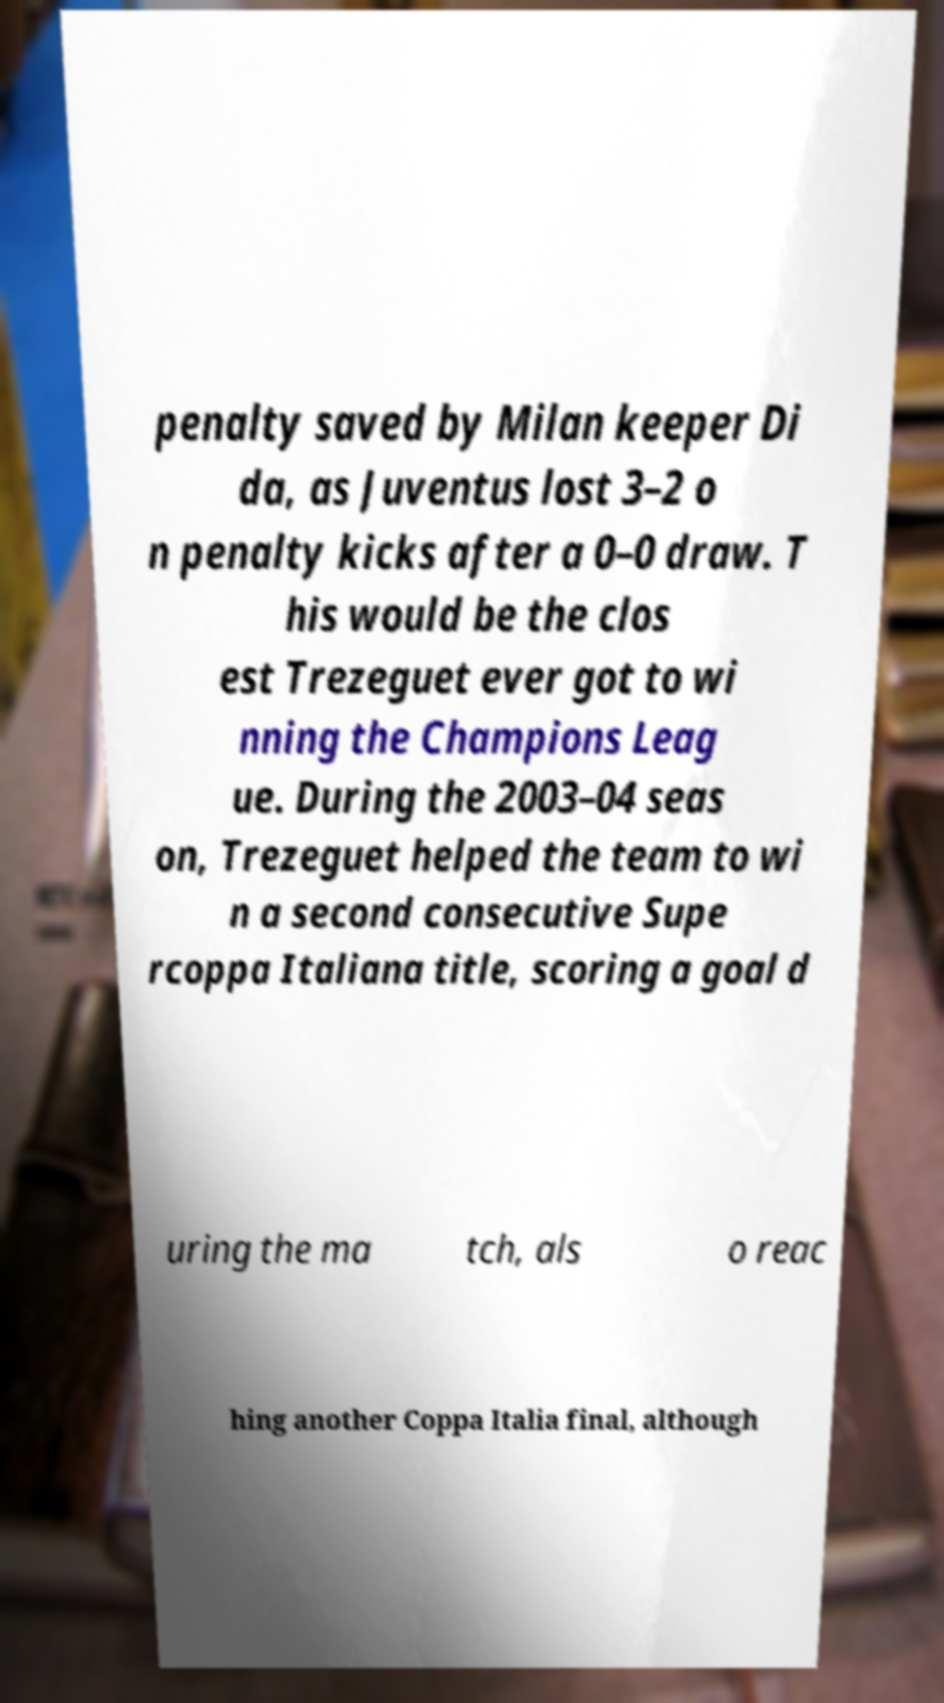Please read and relay the text visible in this image. What does it say? penalty saved by Milan keeper Di da, as Juventus lost 3–2 o n penalty kicks after a 0–0 draw. T his would be the clos est Trezeguet ever got to wi nning the Champions Leag ue. During the 2003–04 seas on, Trezeguet helped the team to wi n a second consecutive Supe rcoppa Italiana title, scoring a goal d uring the ma tch, als o reac hing another Coppa Italia final, although 